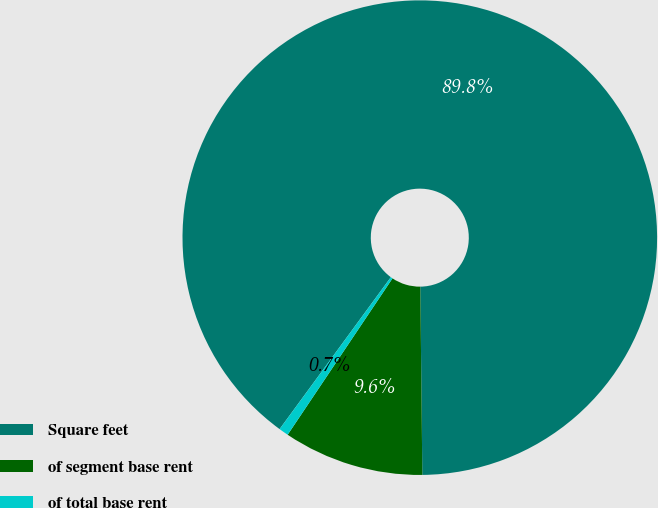<chart> <loc_0><loc_0><loc_500><loc_500><pie_chart><fcel>Square feet<fcel>of segment base rent<fcel>of total base rent<nl><fcel>89.77%<fcel>9.57%<fcel>0.66%<nl></chart> 